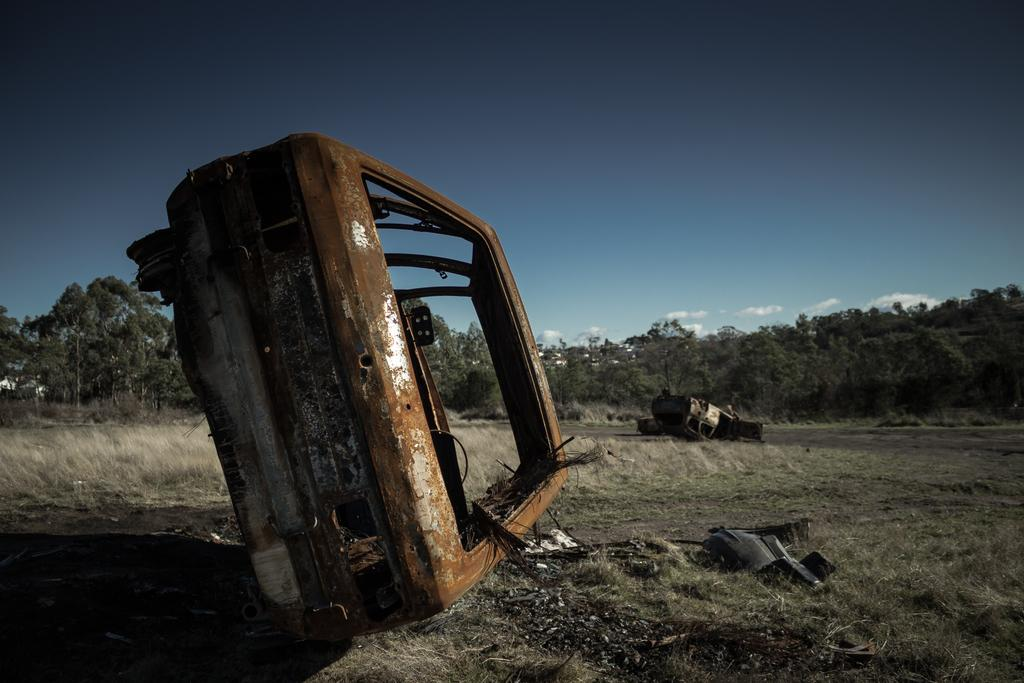What type of vegetation is present in the image? There is dried grass in the image. What else can be seen on the dried grass? There are scrap cars on the dried grass. Can you describe the object in the image? Unfortunately, there is not enough information provided to describe the object in the image. What is visible in the background of the image? There are trees in the background of the image. What is the color of the sky in the image? The sky is blue in color. Are there any additional features in the sky? Yes, there are clouds in the sky. How many copies of the foot can be seen in the image? There are no feet or copies of feet present in the image. What type of coast is visible in the image? There is no coast visible in the image; it features dried grass, scrap cars, trees, and a blue sky with clouds. 